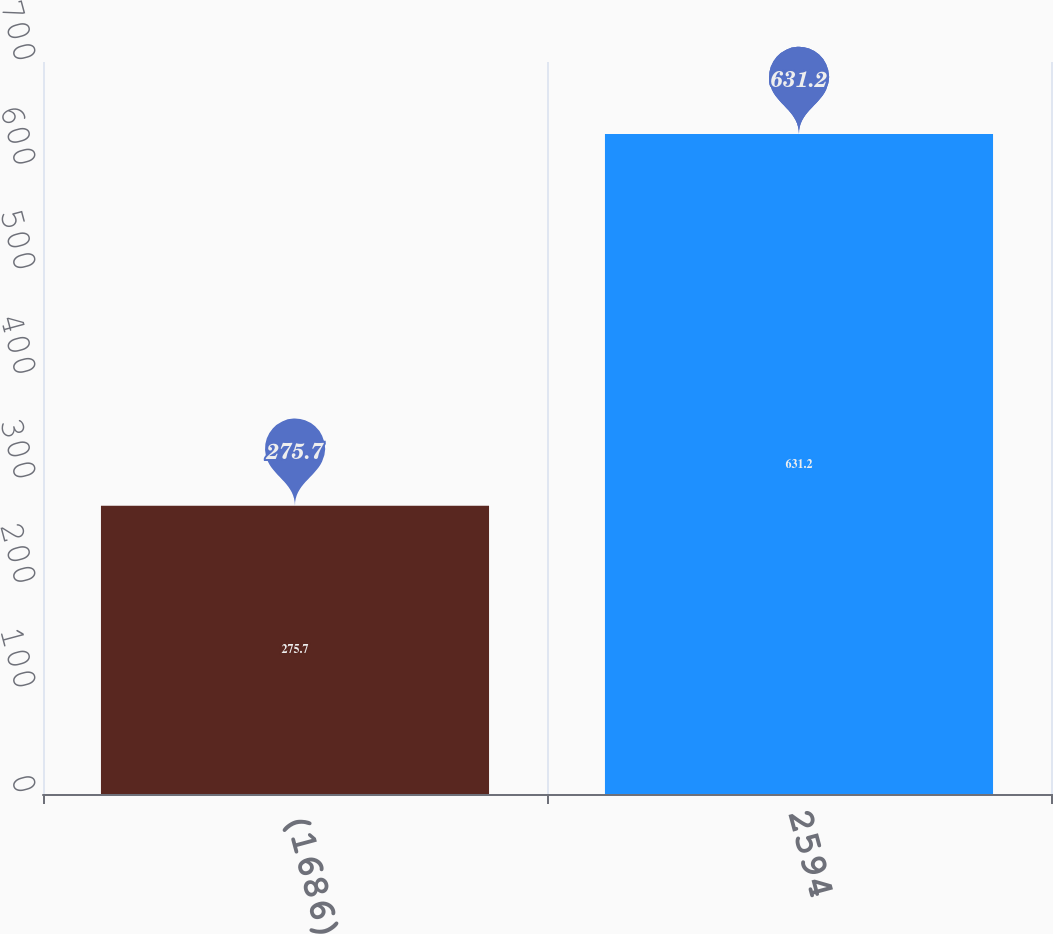<chart> <loc_0><loc_0><loc_500><loc_500><bar_chart><fcel>(1686)<fcel>2594<nl><fcel>275.7<fcel>631.2<nl></chart> 